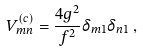<formula> <loc_0><loc_0><loc_500><loc_500>V ^ { ( c ) } _ { m n } = \frac { 4 g ^ { 2 } } { f ^ { 2 } } \delta _ { m 1 } \delta _ { n 1 } \, ,</formula> 